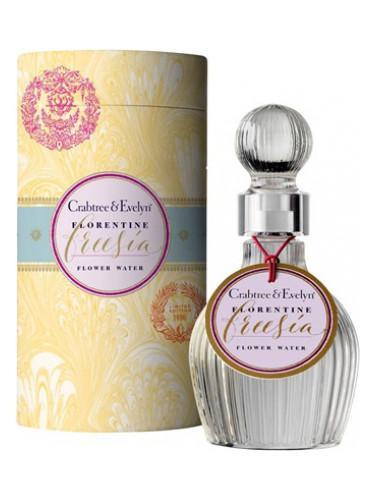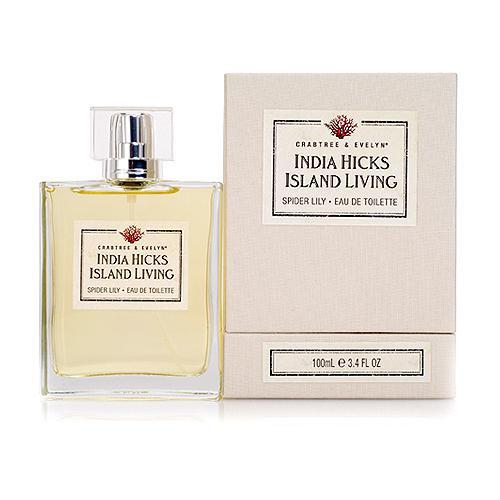The first image is the image on the left, the second image is the image on the right. For the images shown, is this caption "In the image to the right, the fragrance bottle is a different color than its box." true? Answer yes or no. Yes. The first image is the image on the left, the second image is the image on the right. Examine the images to the left and right. Is the description "there are two perfume bottles in the image pair" accurate? Answer yes or no. Yes. 